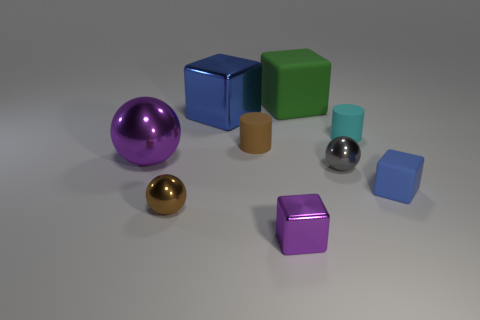Subtract all blue spheres. Subtract all gray cylinders. How many spheres are left? 3 Subtract all blue cylinders. How many purple blocks are left? 1 Add 2 tiny things. How many browns exist? 0 Subtract all blue blocks. Subtract all tiny rubber objects. How many objects are left? 4 Add 3 gray shiny spheres. How many gray shiny spheres are left? 4 Add 9 small cyan rubber objects. How many small cyan rubber objects exist? 10 Add 1 tiny brown shiny spheres. How many objects exist? 10 Subtract all brown balls. How many balls are left? 2 Subtract all small balls. How many balls are left? 1 Subtract 0 yellow balls. How many objects are left? 9 